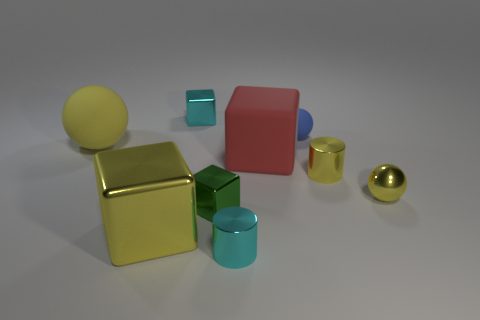Subtract all red cubes. How many yellow balls are left? 2 Subtract all small spheres. How many spheres are left? 1 Add 1 yellow blocks. How many objects exist? 10 Subtract all yellow blocks. How many blocks are left? 3 Subtract all balls. How many objects are left? 6 Subtract all red spheres. Subtract all yellow cylinders. How many spheres are left? 3 Add 5 tiny yellow metal spheres. How many tiny yellow metal spheres exist? 6 Subtract 0 blue blocks. How many objects are left? 9 Subtract all tiny green metal things. Subtract all blue balls. How many objects are left? 7 Add 4 green cubes. How many green cubes are left? 5 